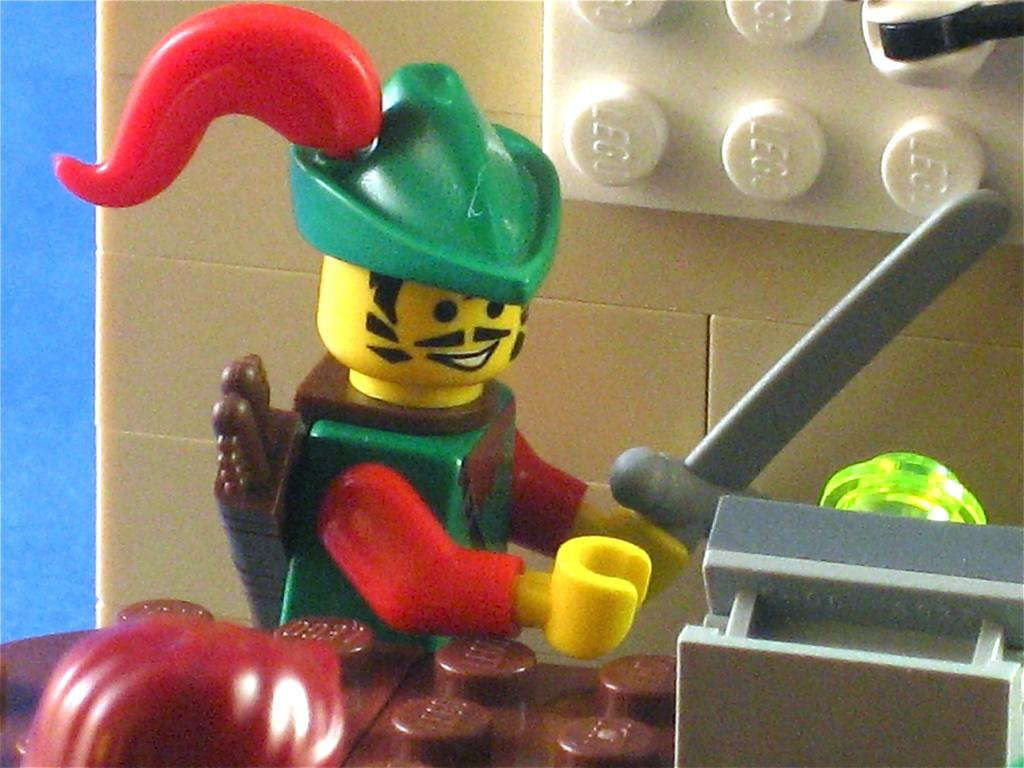What type of objects can be seen in the image? There are toys in the image. Can you describe the toys in more detail? Unfortunately, the image does not provide enough detail to describe the toys further. Are there any other objects or people visible in the image? The facts provided only mention toys, so there is no information about any other objects or people in the image. What is the design of the hair on the toys in the image? There are no toys with hair in the image, as the facts provided only mention toys in general. 